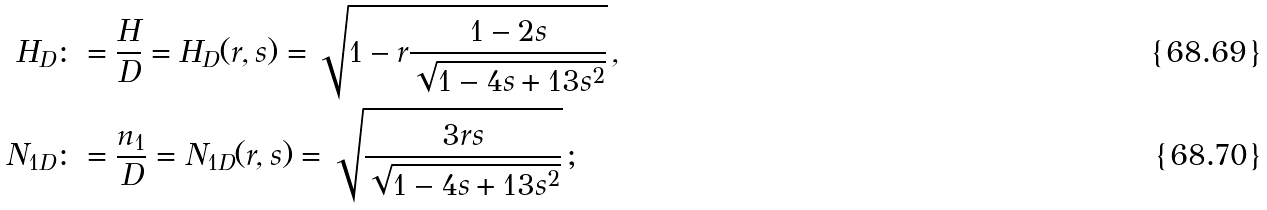<formula> <loc_0><loc_0><loc_500><loc_500>H _ { D } & \colon = \frac { H } { D } = H _ { D } ( r , s ) = \sqrt { 1 - r \frac { 1 - 2 s } { \sqrt { 1 - 4 s + 1 3 s ^ { 2 } } } } \, , \\ N _ { 1 D } & \colon = \frac { n _ { 1 } } { D } = N _ { 1 D } ( r , s ) = \sqrt { \frac { 3 r s } { \sqrt { 1 - 4 s + 1 3 s ^ { 2 } } } } \, ;</formula> 